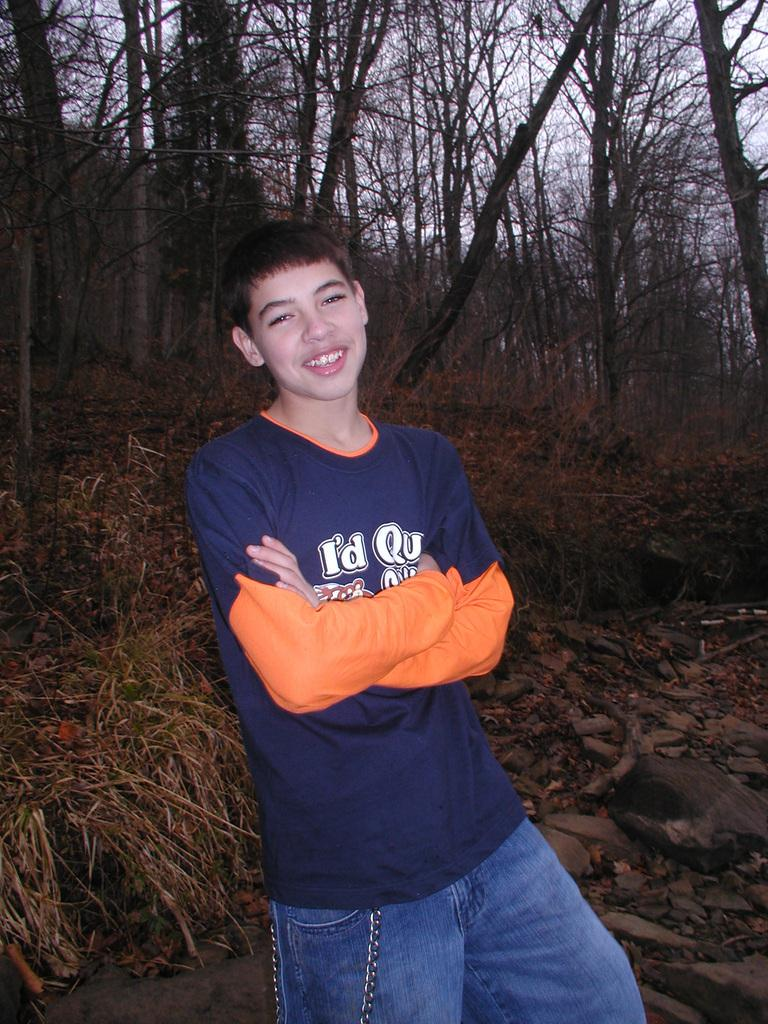Provide a one-sentence caption for the provided image. A boy is wearing a blue tee that says "i'd qu..." but the rest of the text is obscured by his arm. 